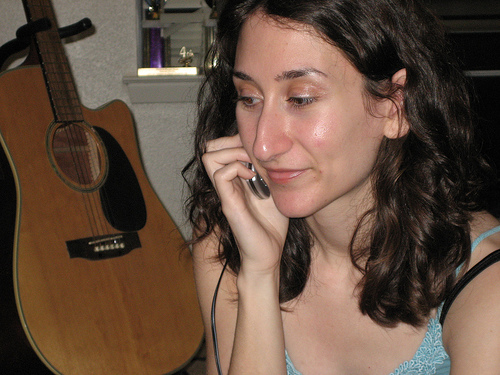<image>
Is the lady behind the guitar? No. The lady is not behind the guitar. From this viewpoint, the lady appears to be positioned elsewhere in the scene. 